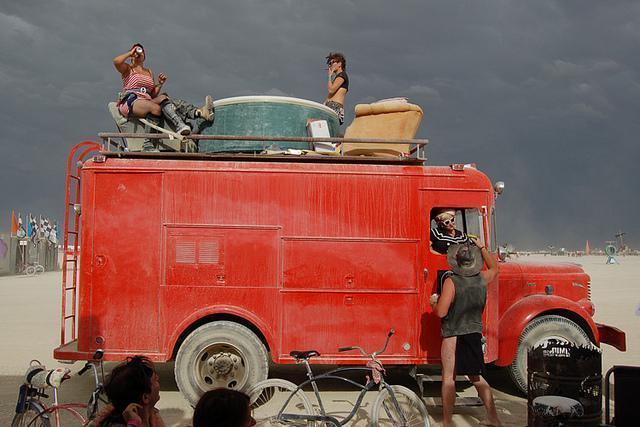Is the statement "The couch is on top of the truck." accurate regarding the image?
Answer yes or no. Yes. Evaluate: Does the caption "The couch is under the truck." match the image?
Answer yes or no. No. 